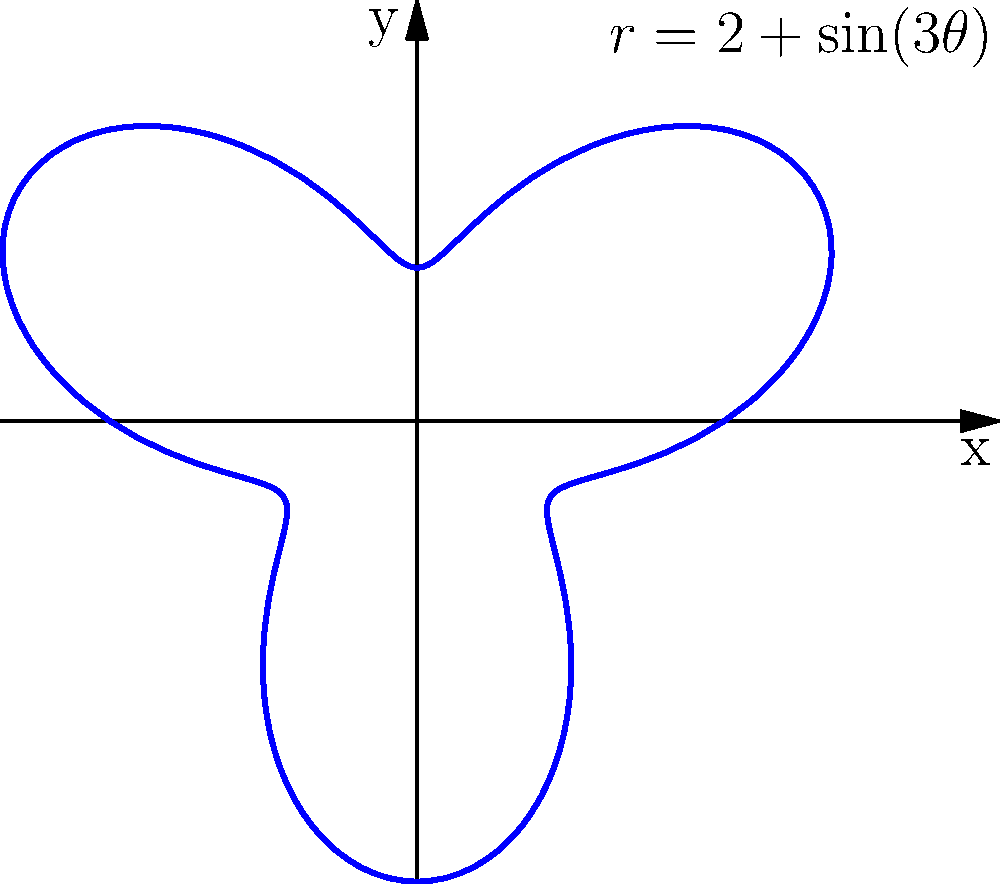You've acquired a uniquely shaped vintage pendant that follows the polar equation $r = 2 + \sin(3\theta)$. To determine its value based on its gold content, you need to calculate its area. Using integration in polar coordinates, find the area of this pendant. Round your answer to two decimal places. To find the area of the pendant using polar coordinates, we'll follow these steps:

1) The formula for the area of a region in polar coordinates is:

   $$A = \frac{1}{2} \int_{0}^{2\pi} r^2(\theta) d\theta$$

2) In this case, $r(\theta) = 2 + \sin(3\theta)$. We need to square this:

   $$r^2(\theta) = (2 + \sin(3\theta))^2 = 4 + 4\sin(3\theta) + \sin^2(3\theta)$$

3) Now, let's set up the integral:

   $$A = \frac{1}{2} \int_{0}^{2\pi} (4 + 4\sin(3\theta) + \sin^2(3\theta)) d\theta$$

4) We can split this into three integrals:

   $$A = \frac{1}{2} \left(\int_{0}^{2\pi} 4 d\theta + \int_{0}^{2\pi} 4\sin(3\theta) d\theta + \int_{0}^{2\pi} \sin^2(3\theta) d\theta\right)$$

5) Let's evaluate each integral:
   - $\int_{0}^{2\pi} 4 d\theta = 4\theta \big|_{0}^{2\pi} = 8\pi$
   - $\int_{0}^{2\pi} 4\sin(3\theta) d\theta = -\frac{4}{3}\cos(3\theta) \big|_{0}^{2\pi} = 0$
   - For the last integral, we can use the identity $\sin^2(x) = \frac{1}{2}(1-\cos(2x))$:
     $$\int_{0}^{2\pi} \sin^2(3\theta) d\theta = \int_{0}^{2\pi} \frac{1}{2}(1-\cos(6\theta)) d\theta = \frac{1}{2}\theta - \frac{1}{12}\sin(6\theta) \big|_{0}^{2\pi} = \pi$$

6) Putting it all together:

   $$A = \frac{1}{2}(8\pi + 0 + \pi) = \frac{9\pi}{2} \approx 14.14$$

Therefore, the area of the pendant is approximately 14.14 square units.
Answer: 14.14 square units 